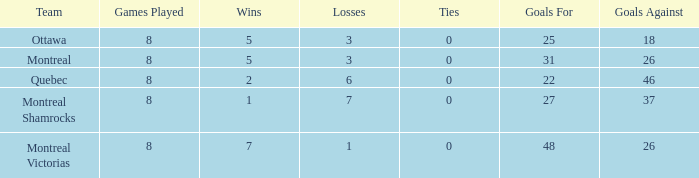Give me the full table as a dictionary. {'header': ['Team', 'Games Played', 'Wins', 'Losses', 'Ties', 'Goals For', 'Goals Against'], 'rows': [['Ottawa', '8', '5', '3', '0', '25', '18'], ['Montreal', '8', '5', '3', '0', '31', '26'], ['Quebec', '8', '2', '6', '0', '22', '46'], ['Montreal Shamrocks', '8', '1', '7', '0', '27', '37'], ['Montreal Victorias', '8', '7', '1', '0', '48', '26']]} For teams with more than 0 ties and goals against of 37, how many wins were tallied? None. 